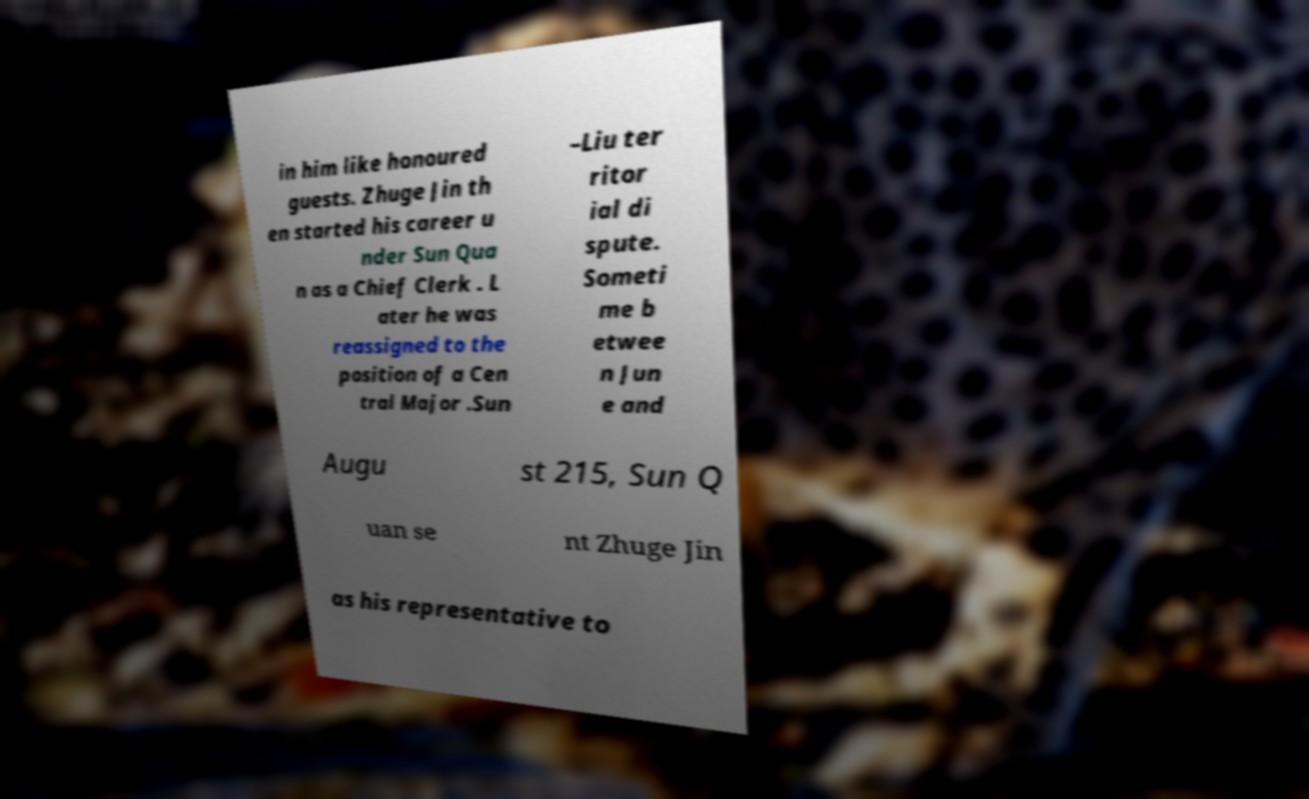For documentation purposes, I need the text within this image transcribed. Could you provide that? in him like honoured guests. Zhuge Jin th en started his career u nder Sun Qua n as a Chief Clerk . L ater he was reassigned to the position of a Cen tral Major .Sun –Liu ter ritor ial di spute. Someti me b etwee n Jun e and Augu st 215, Sun Q uan se nt Zhuge Jin as his representative to 